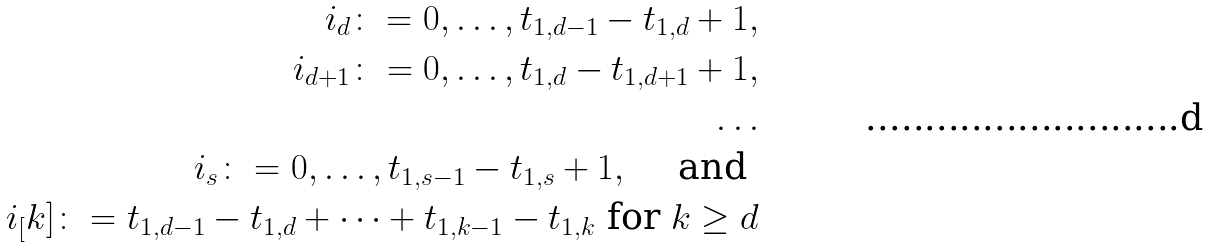Convert formula to latex. <formula><loc_0><loc_0><loc_500><loc_500>i _ { d } \colon = 0 , \dots , t _ { 1 , d - 1 } - t _ { 1 , d } + 1 , \\ i _ { d + 1 } \colon = 0 , \dots , t _ { 1 , d } - t _ { 1 , d + 1 } + 1 , \\ \dots \\ i _ { s } \colon = 0 , \dots , t _ { 1 , s - 1 } - t _ { 1 , s } + 1 , \quad \text { and } \\ i _ { [ } k ] \colon = t _ { 1 , d - 1 } - t _ { 1 , d } + \dots + t _ { 1 , k - 1 } - t _ { 1 , k } \text { for } k \geq d</formula> 